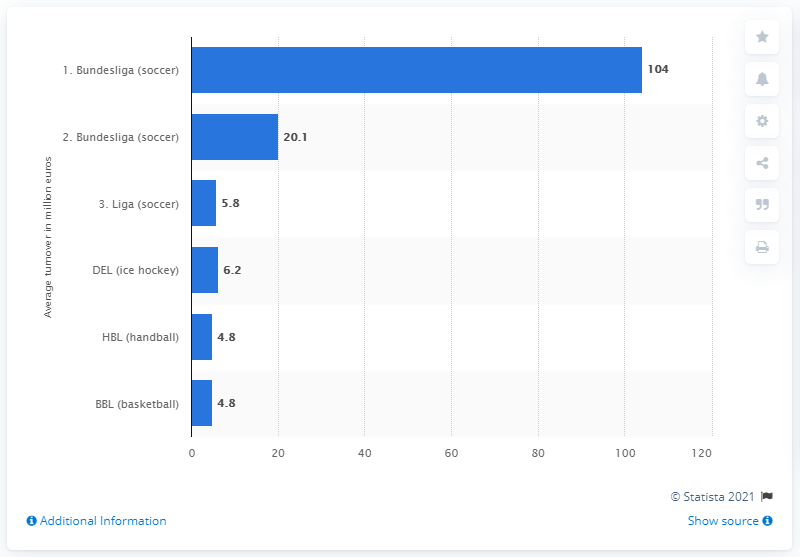Draw attention to some important aspects in this diagram. The turnover of clubs in the second division of German professional football in the 2011/12 season was 20.1%. 